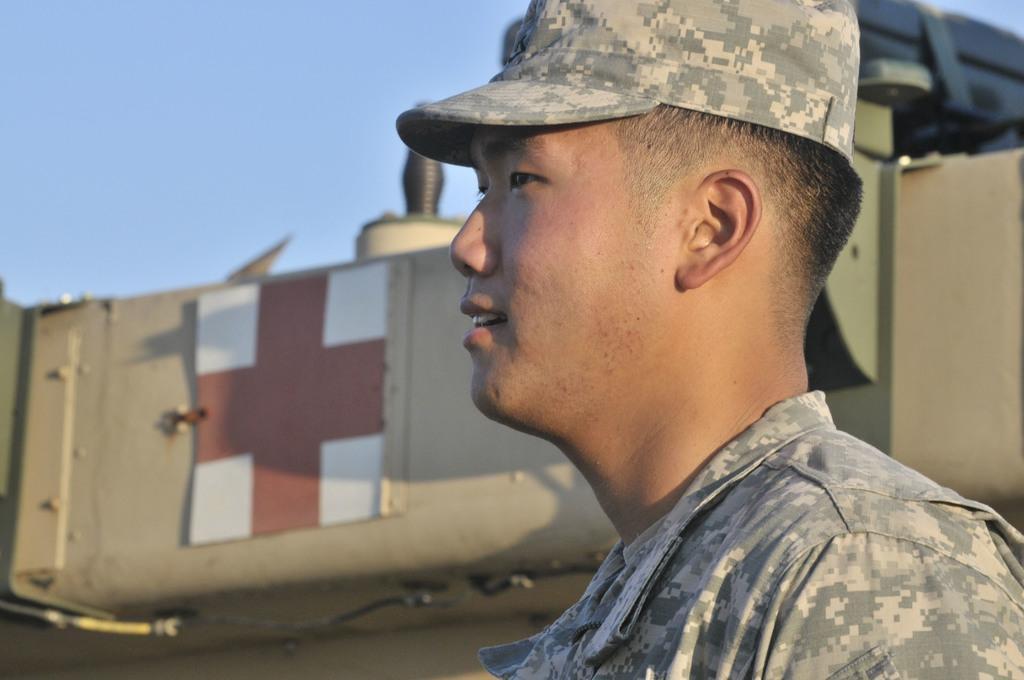Please provide a concise description of this image. In the picture I can see a person wearing army uniform and cap is standing here and smiling. In the background, I can see a vehicle and the blue color sky. 